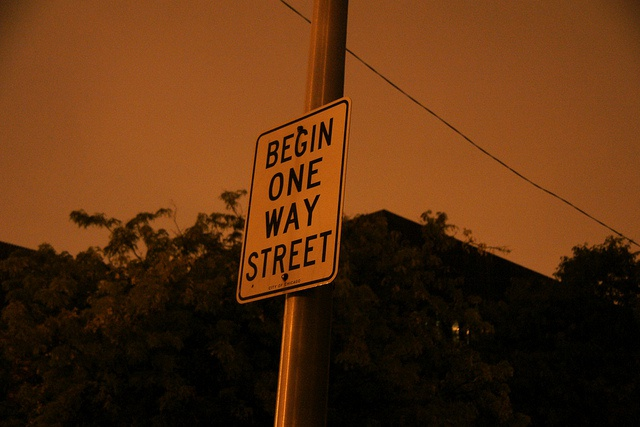Describe the objects in this image and their specific colors. I can see various objects in this image with different colors. 